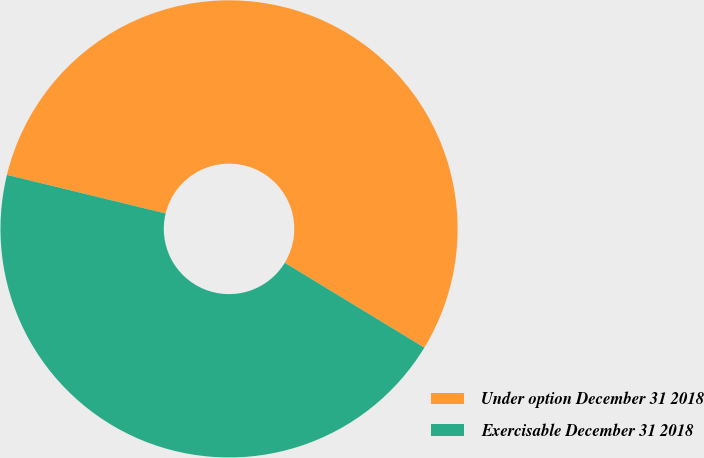Convert chart to OTSL. <chart><loc_0><loc_0><loc_500><loc_500><pie_chart><fcel>Under option December 31 2018<fcel>Exercisable December 31 2018<nl><fcel>54.9%<fcel>45.1%<nl></chart> 